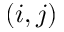Convert formula to latex. <formula><loc_0><loc_0><loc_500><loc_500>( i , j )</formula> 